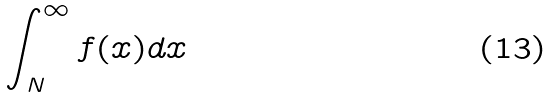Convert formula to latex. <formula><loc_0><loc_0><loc_500><loc_500>\int _ { N } ^ { \infty } f ( x ) d x</formula> 